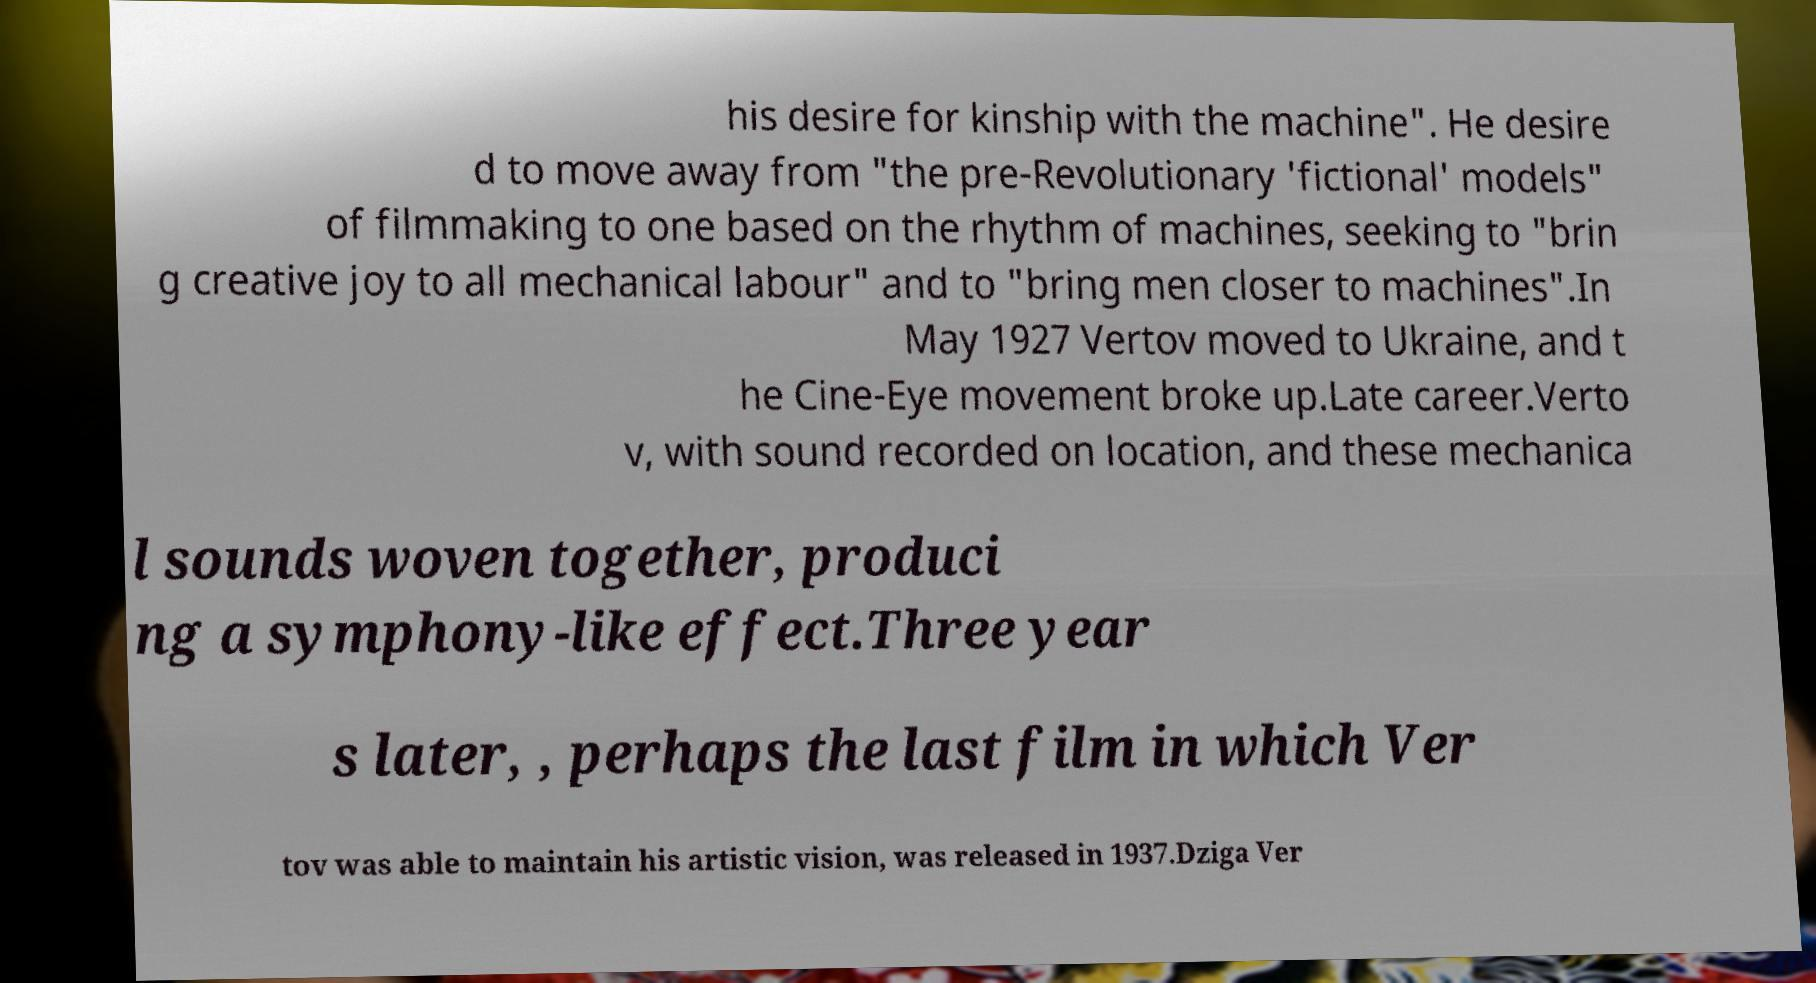There's text embedded in this image that I need extracted. Can you transcribe it verbatim? his desire for kinship with the machine". He desire d to move away from "the pre-Revolutionary 'fictional' models" of filmmaking to one based on the rhythm of machines, seeking to "brin g creative joy to all mechanical labour" and to "bring men closer to machines".In May 1927 Vertov moved to Ukraine, and t he Cine-Eye movement broke up.Late career.Verto v, with sound recorded on location, and these mechanica l sounds woven together, produci ng a symphony-like effect.Three year s later, , perhaps the last film in which Ver tov was able to maintain his artistic vision, was released in 1937.Dziga Ver 